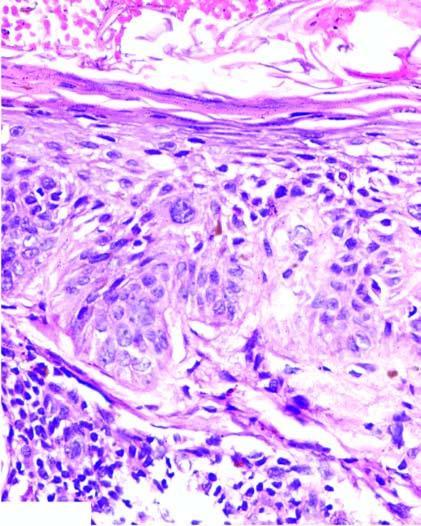re normal non-activated platelet, having open canalicular system and the cytoplasmic organelles bizarre atypical squamous cells but the border between the epidermis and dermis is intact ie?
Answer the question using a single word or phrase. No 